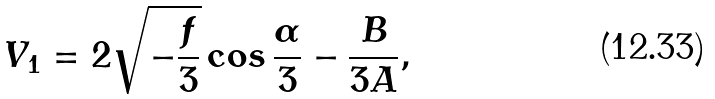<formula> <loc_0><loc_0><loc_500><loc_500>V _ { 1 } = 2 \sqrt { - \frac { f } { 3 } } \cos \frac { \alpha } { 3 } - \frac { B } { 3 A } ,</formula> 